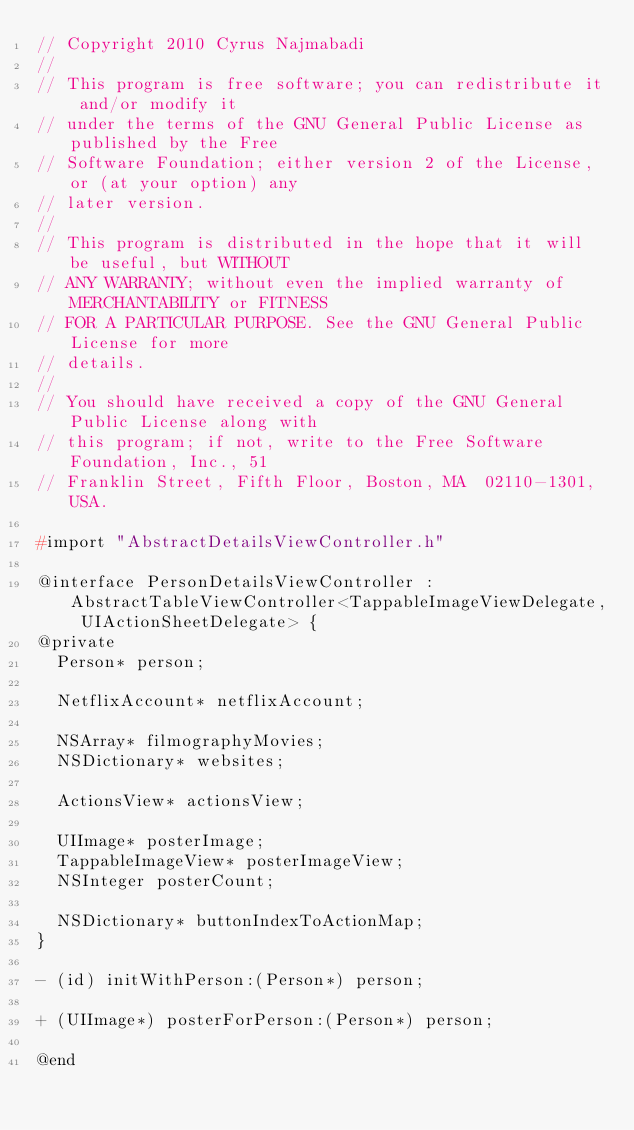Convert code to text. <code><loc_0><loc_0><loc_500><loc_500><_C_>// Copyright 2010 Cyrus Najmabadi
//
// This program is free software; you can redistribute it and/or modify it
// under the terms of the GNU General Public License as published by the Free
// Software Foundation; either version 2 of the License, or (at your option) any
// later version.
//
// This program is distributed in the hope that it will be useful, but WITHOUT
// ANY WARRANTY; without even the implied warranty of MERCHANTABILITY or FITNESS
// FOR A PARTICULAR PURPOSE. See the GNU General Public License for more
// details.
//
// You should have received a copy of the GNU General Public License along with
// this program; if not, write to the Free Software Foundation, Inc., 51
// Franklin Street, Fifth Floor, Boston, MA  02110-1301, USA.

#import "AbstractDetailsViewController.h"

@interface PersonDetailsViewController : AbstractTableViewController<TappableImageViewDelegate, UIActionSheetDelegate> {
@private
  Person* person;

  NetflixAccount* netflixAccount;

  NSArray* filmographyMovies;
  NSDictionary* websites;

  ActionsView* actionsView;

  UIImage* posterImage;
  TappableImageView* posterImageView;
  NSInteger posterCount;

  NSDictionary* buttonIndexToActionMap;
}

- (id) initWithPerson:(Person*) person;

+ (UIImage*) posterForPerson:(Person*) person;

@end
</code> 